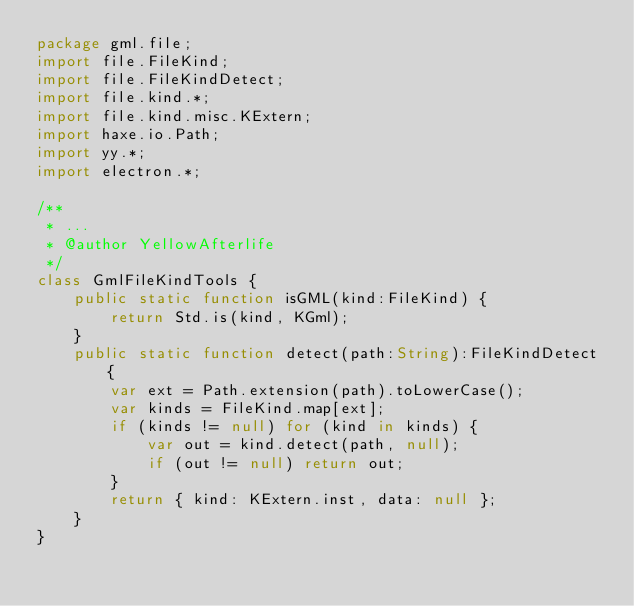<code> <loc_0><loc_0><loc_500><loc_500><_Haxe_>package gml.file;
import file.FileKind;
import file.FileKindDetect;
import file.kind.*;
import file.kind.misc.KExtern;
import haxe.io.Path;
import yy.*;
import electron.*;

/**
 * ...
 * @author YellowAfterlife
 */
class GmlFileKindTools {
	public static function isGML(kind:FileKind) {
		return Std.is(kind, KGml);
	}
	public static function detect(path:String):FileKindDetect {
		var ext = Path.extension(path).toLowerCase();
		var kinds = FileKind.map[ext];
		if (kinds != null) for (kind in kinds) {
			var out = kind.detect(path, null);
			if (out != null) return out;
		}
		return { kind: KExtern.inst, data: null };
	}
}
</code> 